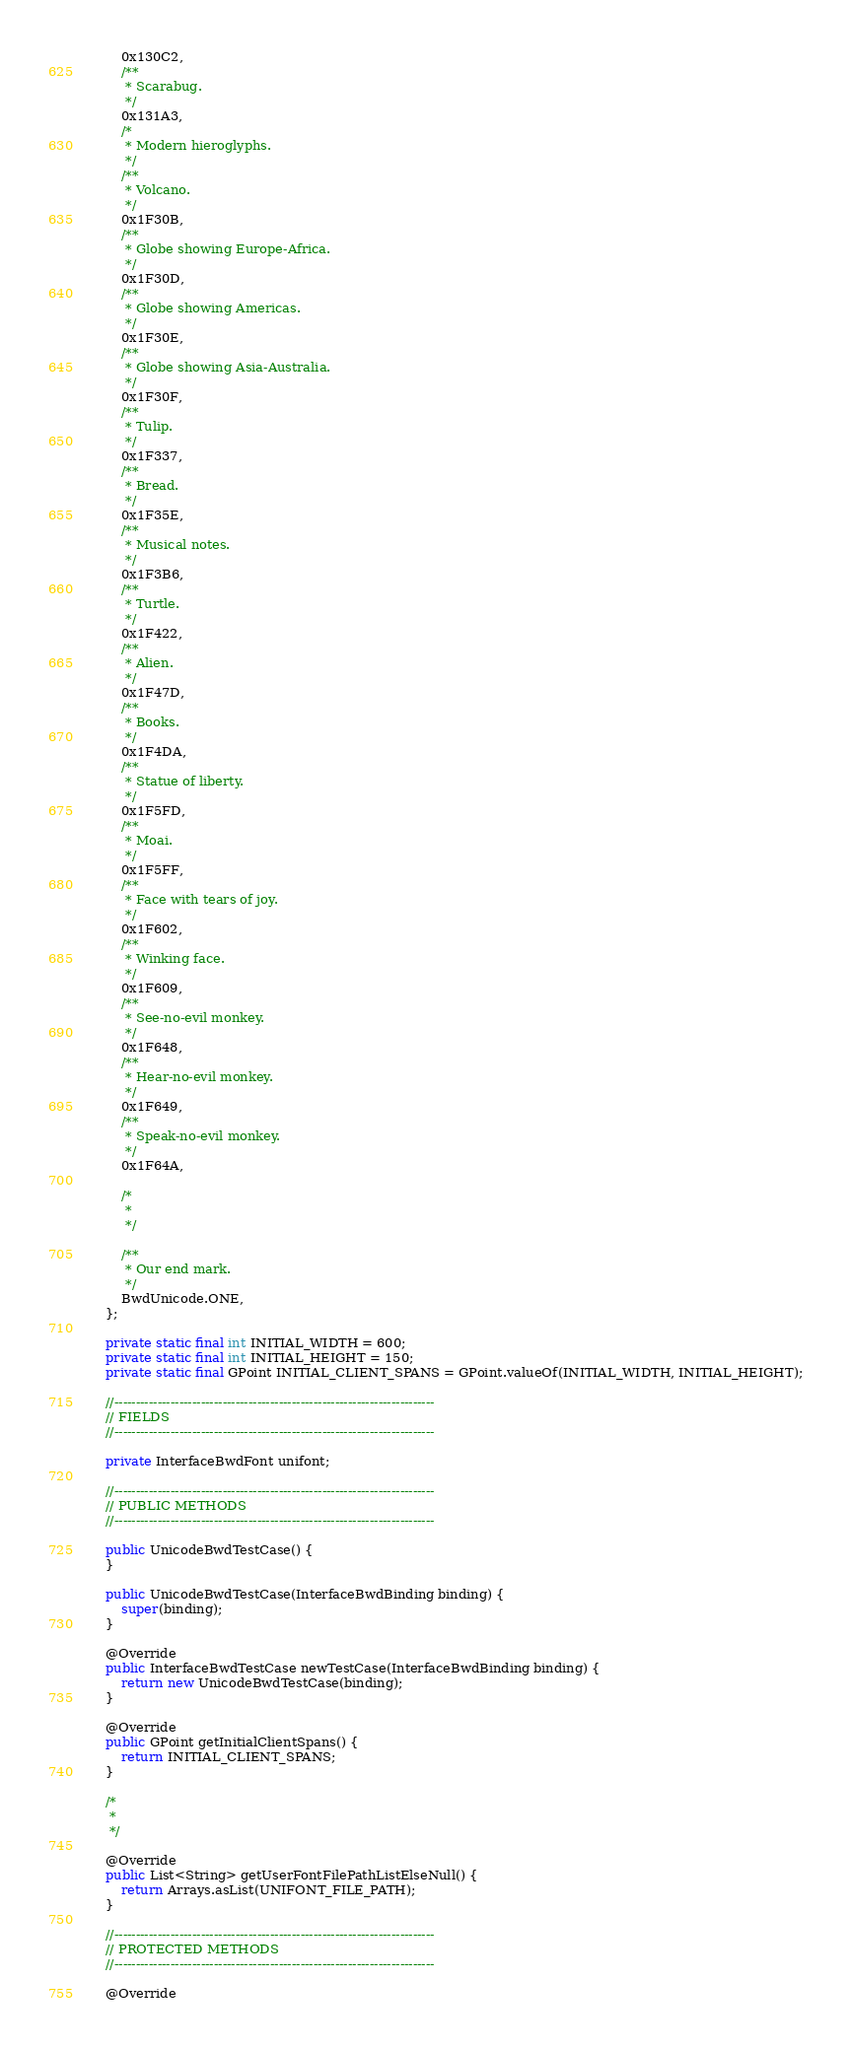Convert code to text. <code><loc_0><loc_0><loc_500><loc_500><_Java_>        0x130C2,
        /**
         * Scarabug.
         */
        0x131A3,
        /*
         * Modern hieroglyphs.
         */
        /**
         * Volcano.
         */
        0x1F30B,
        /**
         * Globe showing Europe-Africa.
         */
        0x1F30D,
        /**
         * Globe showing Americas.
         */
        0x1F30E,
        /**
         * Globe showing Asia-Australia.
         */
        0x1F30F,
        /**
         * Tulip.
         */
        0x1F337,
        /**
         * Bread.
         */
        0x1F35E,
        /**
         * Musical notes.
         */
        0x1F3B6,
        /**
         * Turtle.
         */
        0x1F422,
        /**
         * Alien.
         */
        0x1F47D,
        /**
         * Books.
         */
        0x1F4DA,
        /**
         * Statue of liberty.
         */
        0x1F5FD,
        /**
         * Moai.
         */
        0x1F5FF,
        /**
         * Face with tears of joy.
         */
        0x1F602,
        /**
         * Winking face.
         */
        0x1F609,
        /**
         * See-no-evil monkey.
         */
        0x1F648,
        /**
         * Hear-no-evil monkey.
         */
        0x1F649,
        /**
         * Speak-no-evil monkey.
         */
        0x1F64A,
        
        /*
         * 
         */
        
        /**
         * Our end mark.
         */
        BwdUnicode.ONE,
    };

    private static final int INITIAL_WIDTH = 600;
    private static final int INITIAL_HEIGHT = 150;
    private static final GPoint INITIAL_CLIENT_SPANS = GPoint.valueOf(INITIAL_WIDTH, INITIAL_HEIGHT);

    //--------------------------------------------------------------------------
    // FIELDS
    //--------------------------------------------------------------------------
    
    private InterfaceBwdFont unifont;
    
    //--------------------------------------------------------------------------
    // PUBLIC METHODS
    //--------------------------------------------------------------------------

    public UnicodeBwdTestCase() {
    }

    public UnicodeBwdTestCase(InterfaceBwdBinding binding) {
        super(binding);
    }
    
    @Override
    public InterfaceBwdTestCase newTestCase(InterfaceBwdBinding binding) {
        return new UnicodeBwdTestCase(binding);
    }
    
    @Override
    public GPoint getInitialClientSpans() {
        return INITIAL_CLIENT_SPANS;
    }
    
    /*
     * 
     */
    
    @Override
    public List<String> getUserFontFilePathListElseNull() {
        return Arrays.asList(UNIFONT_FILE_PATH);
    }

    //--------------------------------------------------------------------------
    // PROTECTED METHODS
    //--------------------------------------------------------------------------

    @Override</code> 